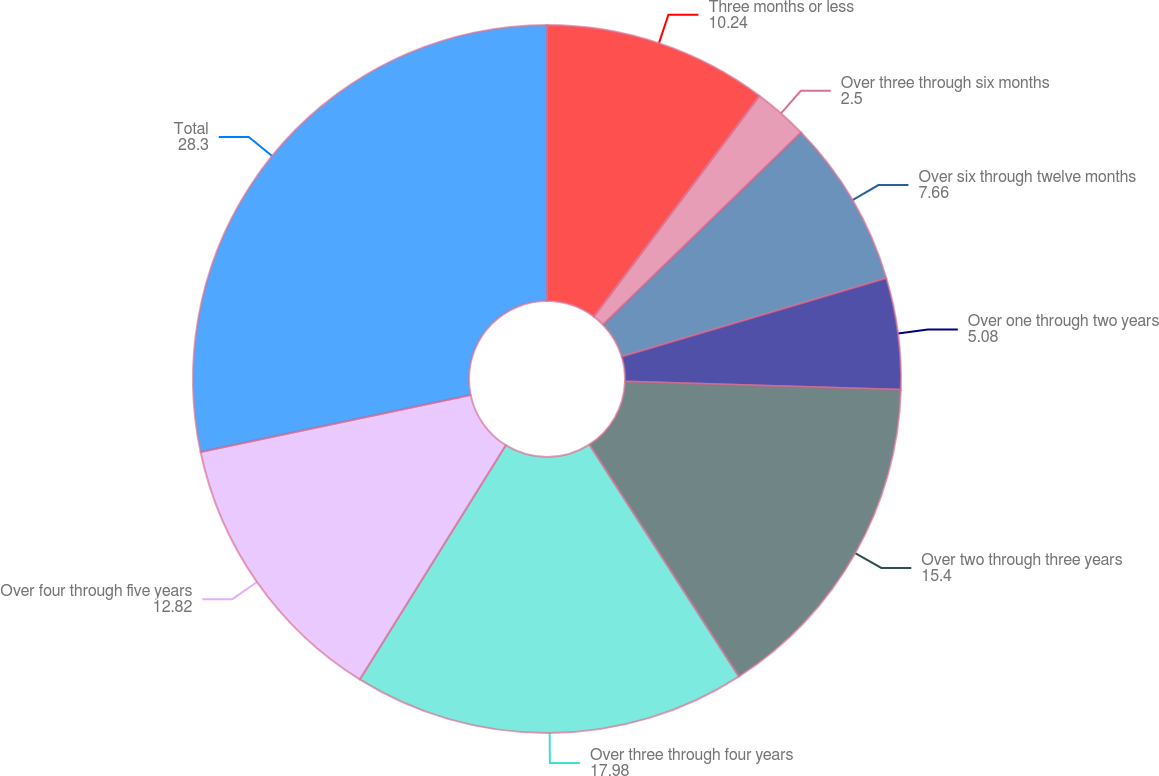<chart> <loc_0><loc_0><loc_500><loc_500><pie_chart><fcel>Three months or less<fcel>Over three through six months<fcel>Over six through twelve months<fcel>Over one through two years<fcel>Over two through three years<fcel>Over three through four years<fcel>Over four through five years<fcel>Total<nl><fcel>10.24%<fcel>2.5%<fcel>7.66%<fcel>5.08%<fcel>15.4%<fcel>17.98%<fcel>12.82%<fcel>28.3%<nl></chart> 